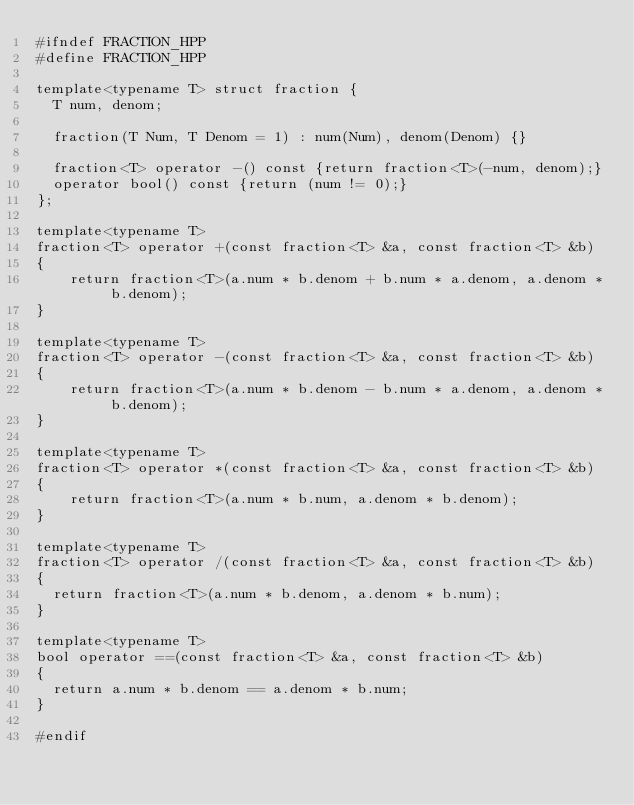<code> <loc_0><loc_0><loc_500><loc_500><_C++_>#ifndef FRACTION_HPP
#define FRACTION_HPP

template<typename T> struct fraction {
	T num, denom;

	fraction(T Num, T Denom = 1) : num(Num), denom(Denom) {}

	fraction<T> operator -() const {return fraction<T>(-num, denom);}
	operator bool() const {return (num != 0);}
};

template<typename T>
fraction<T> operator +(const fraction<T> &a, const fraction<T> &b)
{
    return fraction<T>(a.num * b.denom + b.num * a.denom, a.denom * b.denom);
}

template<typename T>
fraction<T> operator -(const fraction<T> &a, const fraction<T> &b)
{
    return fraction<T>(a.num * b.denom - b.num * a.denom, a.denom * b.denom);
}

template<typename T>
fraction<T> operator *(const fraction<T> &a, const fraction<T> &b)
{
    return fraction<T>(a.num * b.num, a.denom * b.denom);
}

template<typename T>
fraction<T> operator /(const fraction<T> &a, const fraction<T> &b)
{
	return fraction<T>(a.num * b.denom, a.denom * b.num);
}

template<typename T>
bool operator ==(const fraction<T> &a, const fraction<T> &b)
{
	return a.num * b.denom == a.denom * b.num;
}

#endif
</code> 